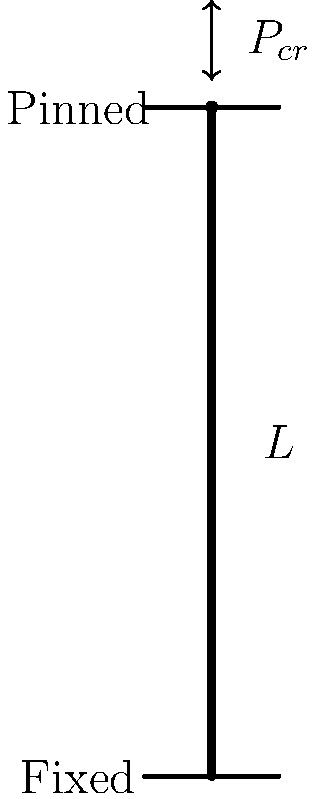As an adventurous engineer inspired by Chris Townsend's spirit of exploration, you encounter a unique structural challenge on a remote hiking trail. You need to determine the critical buckling load ($P_{cr}$) for a column with a fixed base and a pinned top, as shown in the figure. The column has a length $L$, modulus of elasticity $E$, and moment of inertia $I$. Express your answer in terms of these variables. To solve this problem, we'll follow these steps:

1. Recall the general formula for critical buckling load:
   $P_{cr} = \frac{\pi^2 EI}{(KL)^2}$

   Where $K$ is the effective length factor.

2. For a column with one end fixed and one end pinned, the effective length factor $K = 0.699$.

3. Substitute this value into the formula:
   $P_{cr} = \frac{\pi^2 EI}{(0.699L)^2}$

4. Simplify:
   $P_{cr} = \frac{\pi^2 EI}{0.488601L^2}$

5. This can be further simplified to:
   $P_{cr} = \frac{20.19 EI}{L^2}$

This formula gives us the critical buckling load for the column with the specified end conditions.
Answer: $P_{cr} = \frac{20.19 EI}{L^2}$ 